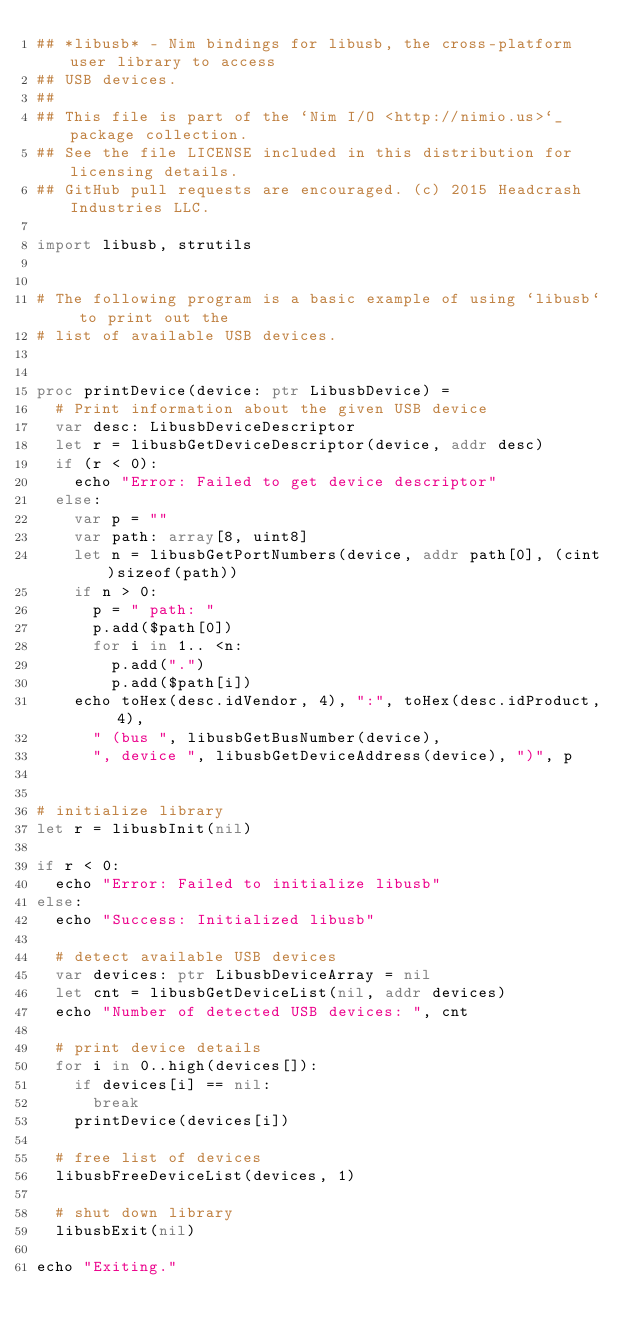Convert code to text. <code><loc_0><loc_0><loc_500><loc_500><_Nim_>## *libusb* - Nim bindings for libusb, the cross-platform user library to access
## USB devices.
##
## This file is part of the `Nim I/O <http://nimio.us>`_ package collection.
## See the file LICENSE included in this distribution for licensing details.
## GitHub pull requests are encouraged. (c) 2015 Headcrash Industries LLC.

import libusb, strutils


# The following program is a basic example of using `libusb` to print out the
# list of available USB devices.


proc printDevice(device: ptr LibusbDevice) =
  # Print information about the given USB device
  var desc: LibusbDeviceDescriptor
  let r = libusbGetDeviceDescriptor(device, addr desc)
  if (r < 0):
    echo "Error: Failed to get device descriptor"
  else:
    var p = ""
    var path: array[8, uint8]
    let n = libusbGetPortNumbers(device, addr path[0], (cint)sizeof(path))
    if n > 0:
      p = " path: "
      p.add($path[0])
      for i in 1.. <n:
        p.add(".")
        p.add($path[i])
    echo toHex(desc.idVendor, 4), ":", toHex(desc.idProduct, 4),
      " (bus ", libusbGetBusNumber(device),
      ", device ", libusbGetDeviceAddress(device), ")", p


# initialize library
let r = libusbInit(nil)

if r < 0:
  echo "Error: Failed to initialize libusb"
else:
  echo "Success: Initialized libusb"

  # detect available USB devices
  var devices: ptr LibusbDeviceArray = nil
  let cnt = libusbGetDeviceList(nil, addr devices)
  echo "Number of detected USB devices: ", cnt

  # print device details
  for i in 0..high(devices[]):
    if devices[i] == nil:
      break
    printDevice(devices[i])

  # free list of devices
  libusbFreeDeviceList(devices, 1)

  # shut down library
  libusbExit(nil)

echo "Exiting."
</code> 